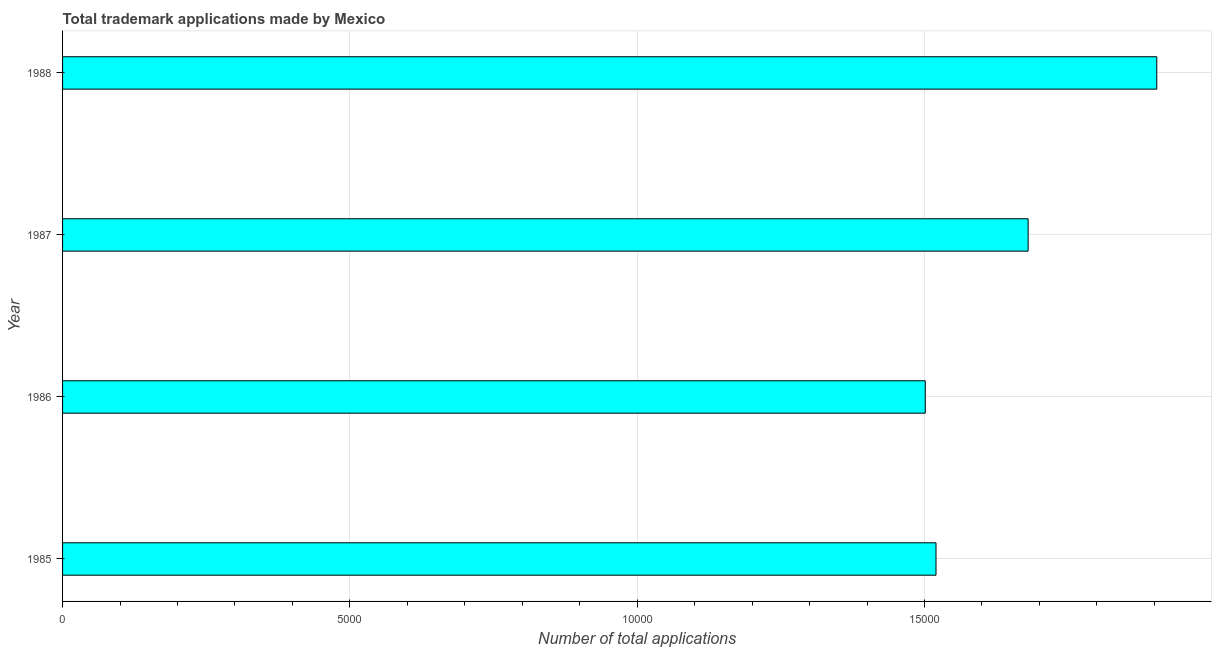Does the graph contain any zero values?
Provide a short and direct response. No. What is the title of the graph?
Provide a short and direct response. Total trademark applications made by Mexico. What is the label or title of the X-axis?
Offer a terse response. Number of total applications. What is the label or title of the Y-axis?
Keep it short and to the point. Year. What is the number of trademark applications in 1987?
Ensure brevity in your answer.  1.68e+04. Across all years, what is the maximum number of trademark applications?
Keep it short and to the point. 1.90e+04. Across all years, what is the minimum number of trademark applications?
Provide a succinct answer. 1.50e+04. In which year was the number of trademark applications maximum?
Your answer should be compact. 1988. What is the sum of the number of trademark applications?
Make the answer very short. 6.61e+04. What is the difference between the number of trademark applications in 1985 and 1988?
Give a very brief answer. -3842. What is the average number of trademark applications per year?
Provide a short and direct response. 1.65e+04. What is the median number of trademark applications?
Give a very brief answer. 1.60e+04. In how many years, is the number of trademark applications greater than 11000 ?
Your response must be concise. 4. What is the ratio of the number of trademark applications in 1985 to that in 1987?
Offer a terse response. 0.91. Is the difference between the number of trademark applications in 1986 and 1988 greater than the difference between any two years?
Your response must be concise. Yes. What is the difference between the highest and the second highest number of trademark applications?
Provide a succinct answer. 2239. What is the difference between the highest and the lowest number of trademark applications?
Make the answer very short. 4029. In how many years, is the number of trademark applications greater than the average number of trademark applications taken over all years?
Provide a succinct answer. 2. How many bars are there?
Make the answer very short. 4. Are all the bars in the graph horizontal?
Give a very brief answer. Yes. What is the difference between two consecutive major ticks on the X-axis?
Offer a very short reply. 5000. Are the values on the major ticks of X-axis written in scientific E-notation?
Your response must be concise. No. What is the Number of total applications of 1985?
Provide a short and direct response. 1.52e+04. What is the Number of total applications in 1986?
Your answer should be very brief. 1.50e+04. What is the Number of total applications in 1987?
Your response must be concise. 1.68e+04. What is the Number of total applications of 1988?
Keep it short and to the point. 1.90e+04. What is the difference between the Number of total applications in 1985 and 1986?
Make the answer very short. 187. What is the difference between the Number of total applications in 1985 and 1987?
Your answer should be compact. -1603. What is the difference between the Number of total applications in 1985 and 1988?
Keep it short and to the point. -3842. What is the difference between the Number of total applications in 1986 and 1987?
Offer a terse response. -1790. What is the difference between the Number of total applications in 1986 and 1988?
Your answer should be very brief. -4029. What is the difference between the Number of total applications in 1987 and 1988?
Ensure brevity in your answer.  -2239. What is the ratio of the Number of total applications in 1985 to that in 1987?
Give a very brief answer. 0.91. What is the ratio of the Number of total applications in 1985 to that in 1988?
Ensure brevity in your answer.  0.8. What is the ratio of the Number of total applications in 1986 to that in 1987?
Your answer should be compact. 0.89. What is the ratio of the Number of total applications in 1986 to that in 1988?
Make the answer very short. 0.79. What is the ratio of the Number of total applications in 1987 to that in 1988?
Your answer should be very brief. 0.88. 